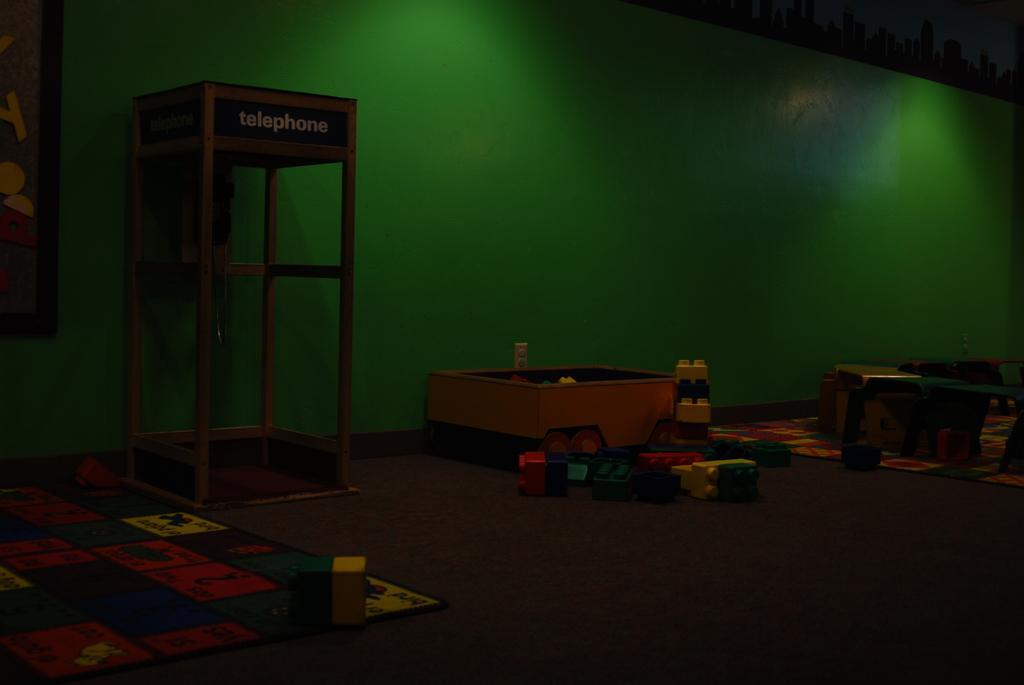Describe this image in one or two sentences. In this picture I can observe building blocks placed on the floor. On the left side there is a telephone booth. In the background I can observe a green color wall. 